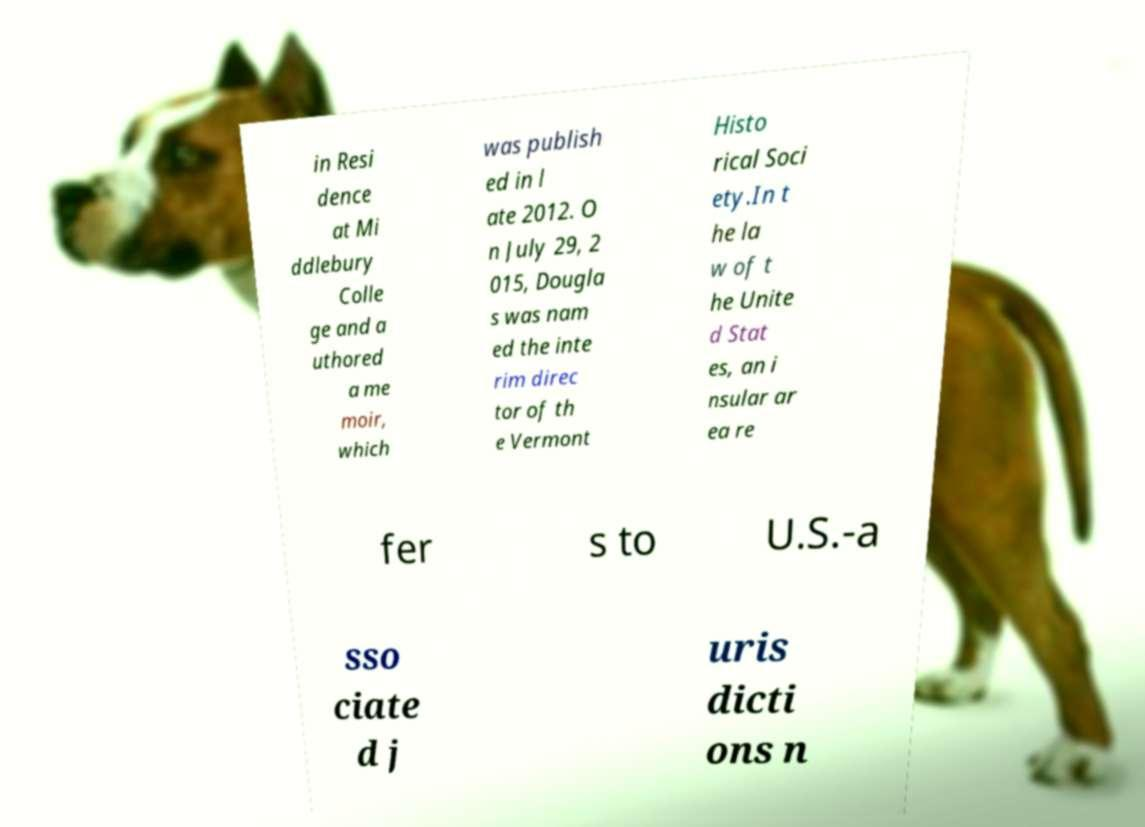Please identify and transcribe the text found in this image. in Resi dence at Mi ddlebury Colle ge and a uthored a me moir, which was publish ed in l ate 2012. O n July 29, 2 015, Dougla s was nam ed the inte rim direc tor of th e Vermont Histo rical Soci ety.In t he la w of t he Unite d Stat es, an i nsular ar ea re fer s to U.S.-a sso ciate d j uris dicti ons n 